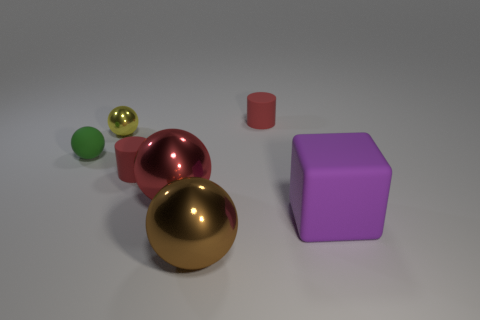There is a sphere that is in front of the purple object; is its size the same as the tiny metallic thing?
Your answer should be compact. No. There is a small thing to the left of the tiny yellow ball; what is its shape?
Keep it short and to the point. Sphere. Is the color of the small thing in front of the green rubber object the same as the large matte thing?
Ensure brevity in your answer.  No. How many things are to the left of the large purple block and to the right of the small yellow metal object?
Your answer should be very brief. 4. Are the yellow ball and the brown object made of the same material?
Keep it short and to the point. Yes. There is a big purple thing in front of the cylinder behind the shiny thing that is behind the large red metallic thing; what is its shape?
Provide a short and direct response. Cube. There is a small thing that is both in front of the yellow shiny ball and to the right of the green object; what is it made of?
Your answer should be very brief. Rubber. There is a tiny cylinder that is in front of the tiny matte cylinder to the right of the red matte cylinder in front of the small green matte object; what is its color?
Your answer should be very brief. Red. How many other objects are there of the same size as the brown object?
Offer a terse response. 2. How many rubber objects are there?
Offer a very short reply. 4. 